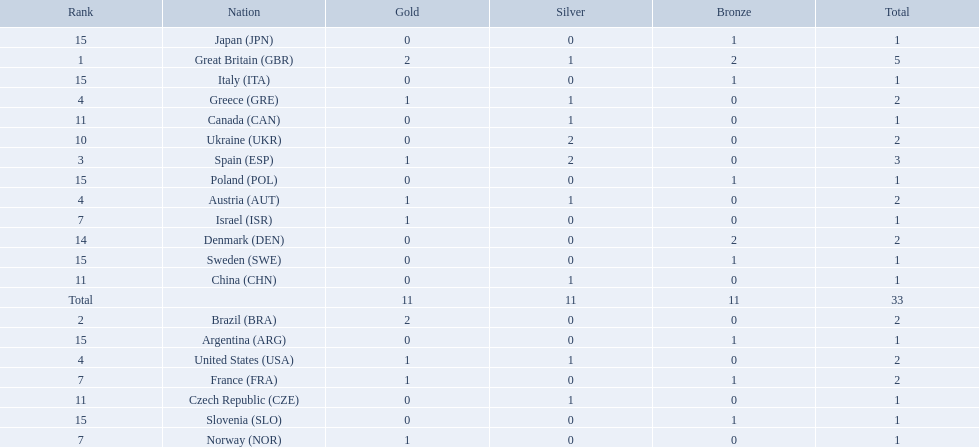How many medals did spain gain 3. Only country that got more medals? Spain (ESP). 